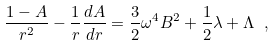Convert formula to latex. <formula><loc_0><loc_0><loc_500><loc_500>\frac { 1 - A } { r ^ { 2 } } - \frac { 1 } { r } \frac { d A } { d r } = \frac { 3 } { 2 } \omega ^ { 4 } B ^ { 2 } + \frac { 1 } { 2 } \lambda + \Lambda \ ,</formula> 